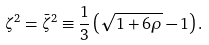Convert formula to latex. <formula><loc_0><loc_0><loc_500><loc_500>\zeta ^ { 2 } = \bar { \zeta } ^ { 2 } \equiv \frac { 1 } { 3 } \left ( \sqrt { 1 + 6 \rho } - 1 \right ) .</formula> 